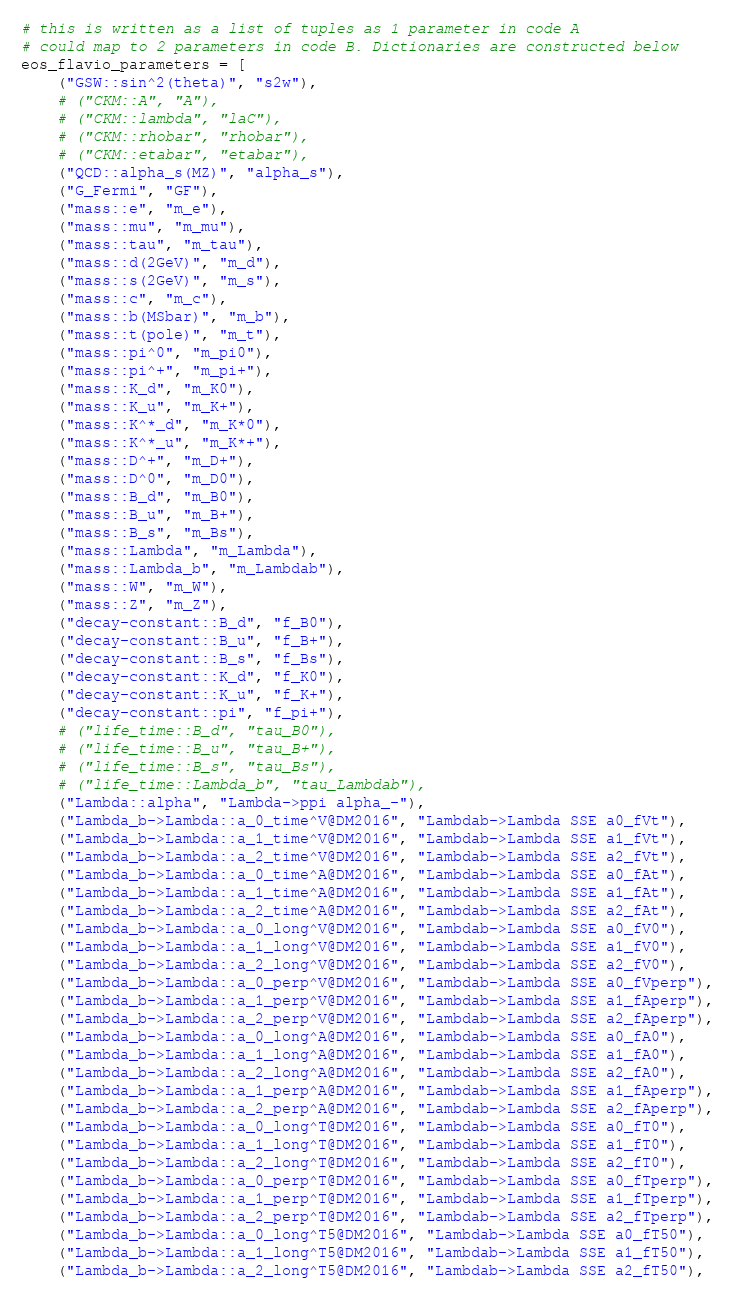Convert code to text. <code><loc_0><loc_0><loc_500><loc_500><_Python_># this is written as a list of tuples as 1 parameter in code A
# could map to 2 parameters in code B. Dictionaries are constructed below
eos_flavio_parameters = [
    ("GSW::sin^2(theta)", "s2w"),
    # ("CKM::A", "A"),
    # ("CKM::lambda", "laC"),
    # ("CKM::rhobar", "rhobar"),
    # ("CKM::etabar", "etabar"),
    ("QCD::alpha_s(MZ)", "alpha_s"),
    ("G_Fermi", "GF"),
    ("mass::e", "m_e"),
    ("mass::mu", "m_mu"),
    ("mass::tau", "m_tau"),
    ("mass::d(2GeV)", "m_d"),
    ("mass::s(2GeV)", "m_s"),
    ("mass::c", "m_c"),
    ("mass::b(MSbar)", "m_b"),
    ("mass::t(pole)", "m_t"),
    ("mass::pi^0", "m_pi0"),
    ("mass::pi^+", "m_pi+"),
    ("mass::K_d", "m_K0"),
    ("mass::K_u", "m_K+"),
    ("mass::K^*_d", "m_K*0"),
    ("mass::K^*_u", "m_K*+"),
    ("mass::D^+", "m_D+"),
    ("mass::D^0", "m_D0"),
    ("mass::B_d", "m_B0"),
    ("mass::B_u", "m_B+"),
    ("mass::B_s", "m_Bs"),
    ("mass::Lambda", "m_Lambda"),
    ("mass::Lambda_b", "m_Lambdab"),
    ("mass::W", "m_W"),
    ("mass::Z", "m_Z"),
    ("decay-constant::B_d", "f_B0"),
    ("decay-constant::B_u", "f_B+"),
    ("decay-constant::B_s", "f_Bs"),
    ("decay-constant::K_d", "f_K0"),
    ("decay-constant::K_u", "f_K+"),
    ("decay-constant::pi", "f_pi+"),
    # ("life_time::B_d", "tau_B0"),
    # ("life_time::B_u", "tau_B+"),
    # ("life_time::B_s", "tau_Bs"),
    # ("life_time::Lambda_b", "tau_Lambdab"),
    ("Lambda::alpha", "Lambda->ppi alpha_-"),
    ("Lambda_b->Lambda::a_0_time^V@DM2016", "Lambdab->Lambda SSE a0_fVt"),
    ("Lambda_b->Lambda::a_1_time^V@DM2016", "Lambdab->Lambda SSE a1_fVt"),
    ("Lambda_b->Lambda::a_2_time^V@DM2016", "Lambdab->Lambda SSE a2_fVt"),
    ("Lambda_b->Lambda::a_0_time^A@DM2016", "Lambdab->Lambda SSE a0_fAt"),
    ("Lambda_b->Lambda::a_1_time^A@DM2016", "Lambdab->Lambda SSE a1_fAt"),
    ("Lambda_b->Lambda::a_2_time^A@DM2016", "Lambdab->Lambda SSE a2_fAt"),
    ("Lambda_b->Lambda::a_0_long^V@DM2016", "Lambdab->Lambda SSE a0_fV0"),
    ("Lambda_b->Lambda::a_1_long^V@DM2016", "Lambdab->Lambda SSE a1_fV0"),
    ("Lambda_b->Lambda::a_2_long^V@DM2016", "Lambdab->Lambda SSE a2_fV0"),
    ("Lambda_b->Lambda::a_0_perp^V@DM2016", "Lambdab->Lambda SSE a0_fVperp"),
    ("Lambda_b->Lambda::a_1_perp^V@DM2016", "Lambdab->Lambda SSE a1_fAperp"),
    ("Lambda_b->Lambda::a_2_perp^V@DM2016", "Lambdab->Lambda SSE a2_fAperp"),
    ("Lambda_b->Lambda::a_0_long^A@DM2016", "Lambdab->Lambda SSE a0_fA0"),
    ("Lambda_b->Lambda::a_1_long^A@DM2016", "Lambdab->Lambda SSE a1_fA0"),
    ("Lambda_b->Lambda::a_2_long^A@DM2016", "Lambdab->Lambda SSE a2_fA0"),
    ("Lambda_b->Lambda::a_1_perp^A@DM2016", "Lambdab->Lambda SSE a1_fAperp"),
    ("Lambda_b->Lambda::a_2_perp^A@DM2016", "Lambdab->Lambda SSE a2_fAperp"),
    ("Lambda_b->Lambda::a_0_long^T@DM2016", "Lambdab->Lambda SSE a0_fT0"),
    ("Lambda_b->Lambda::a_1_long^T@DM2016", "Lambdab->Lambda SSE a1_fT0"),
    ("Lambda_b->Lambda::a_2_long^T@DM2016", "Lambdab->Lambda SSE a2_fT0"),
    ("Lambda_b->Lambda::a_0_perp^T@DM2016", "Lambdab->Lambda SSE a0_fTperp"),
    ("Lambda_b->Lambda::a_1_perp^T@DM2016", "Lambdab->Lambda SSE a1_fTperp"),
    ("Lambda_b->Lambda::a_2_perp^T@DM2016", "Lambdab->Lambda SSE a2_fTperp"),
    ("Lambda_b->Lambda::a_0_long^T5@DM2016", "Lambdab->Lambda SSE a0_fT50"),
    ("Lambda_b->Lambda::a_1_long^T5@DM2016", "Lambdab->Lambda SSE a1_fT50"),
    ("Lambda_b->Lambda::a_2_long^T5@DM2016", "Lambdab->Lambda SSE a2_fT50"),</code> 